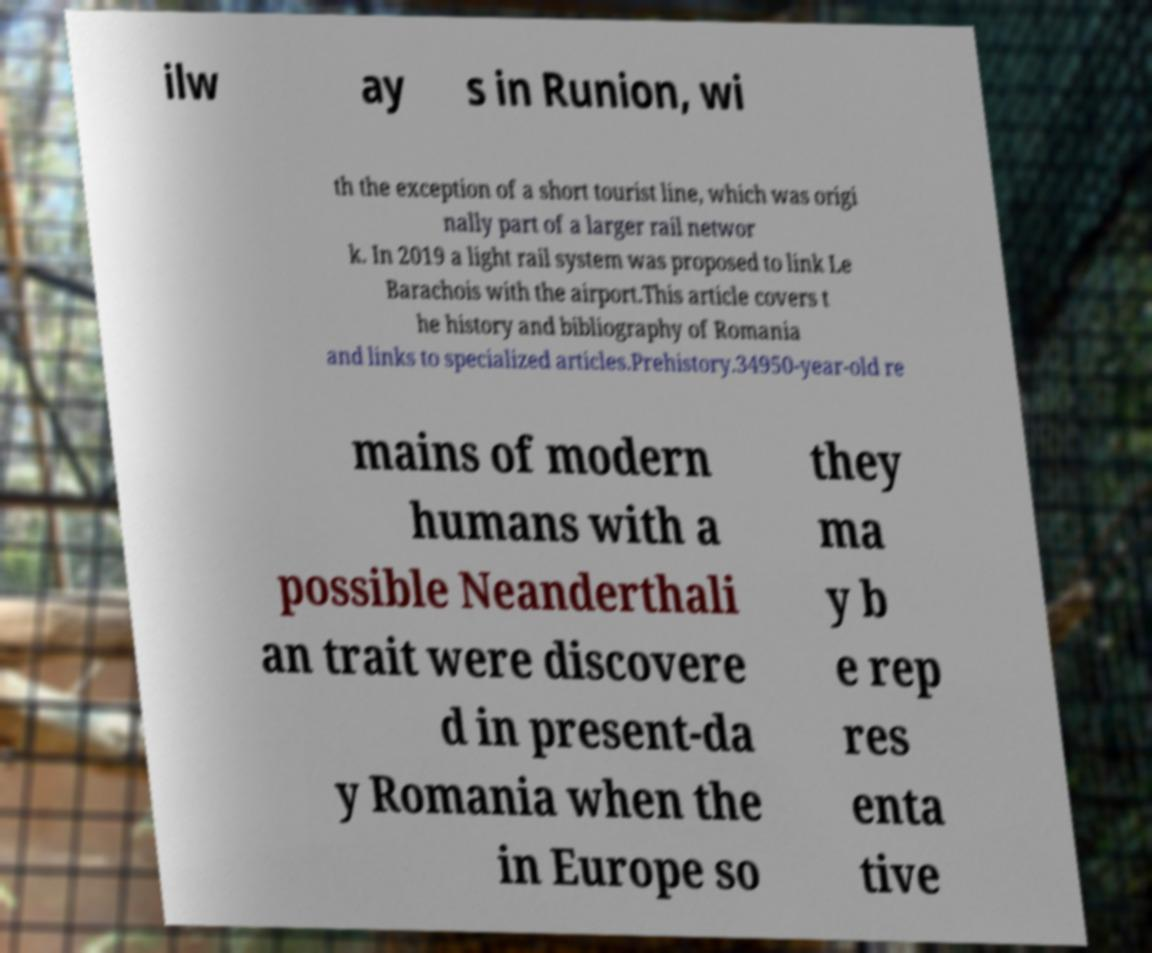Could you extract and type out the text from this image? ilw ay s in Runion, wi th the exception of a short tourist line, which was origi nally part of a larger rail networ k. In 2019 a light rail system was proposed to link Le Barachois with the airport.This article covers t he history and bibliography of Romania and links to specialized articles.Prehistory.34950-year-old re mains of modern humans with a possible Neanderthali an trait were discovere d in present-da y Romania when the in Europe so they ma y b e rep res enta tive 